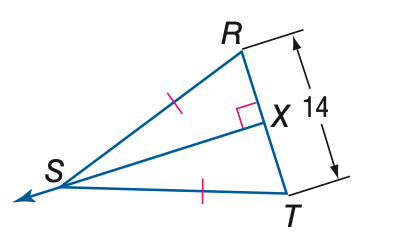Question: Find the measure of X T.
Choices:
A. 3.5
B. 7
C. 14
D. 28
Answer with the letter. Answer: B 